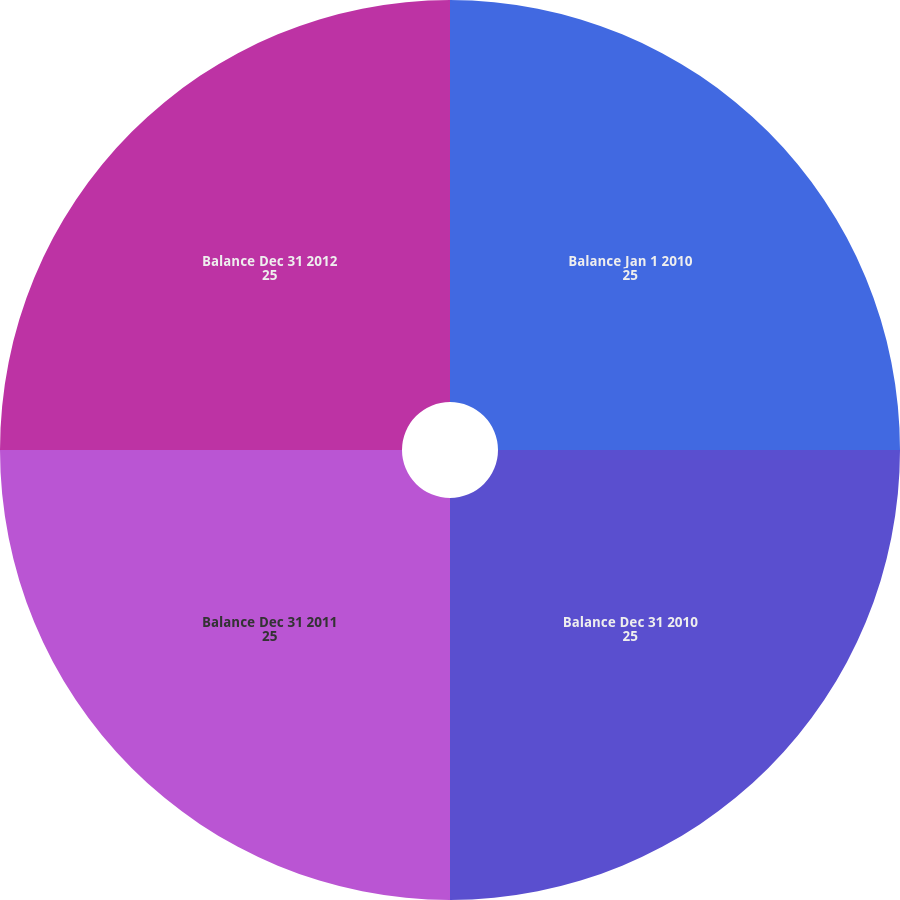<chart> <loc_0><loc_0><loc_500><loc_500><pie_chart><fcel>Balance Jan 1 2010<fcel>Balance Dec 31 2010<fcel>Balance Dec 31 2011<fcel>Balance Dec 31 2012<nl><fcel>25.0%<fcel>25.0%<fcel>25.0%<fcel>25.0%<nl></chart> 